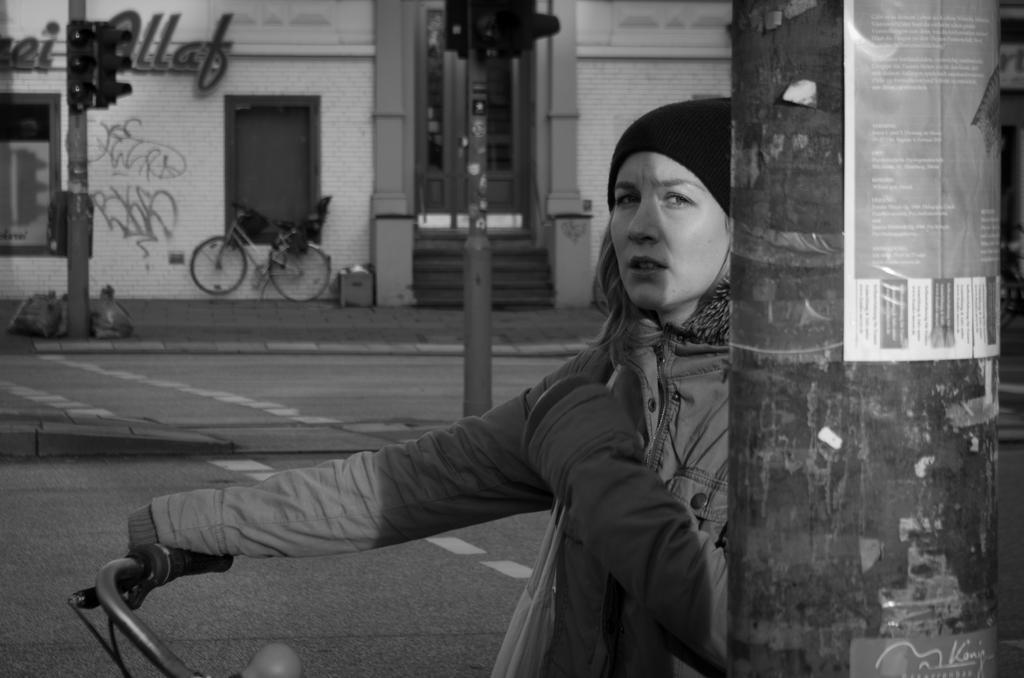Could you give a brief overview of what you see in this image? There is a lady wearing a jacket is holding a bicycle. In the background there are traffic lights and a building. There is a bicycle near the building. On the right side there is a pole with sticker on it. 